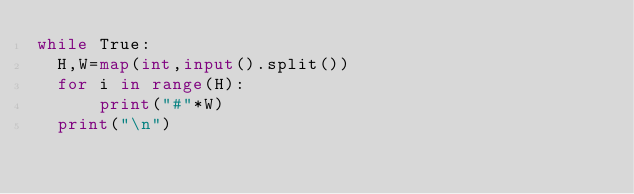<code> <loc_0><loc_0><loc_500><loc_500><_Python_>while True:
  H,W=map(int,input().split())
  for i in range(H):
      print("#"*W)
  print("\n")
</code> 